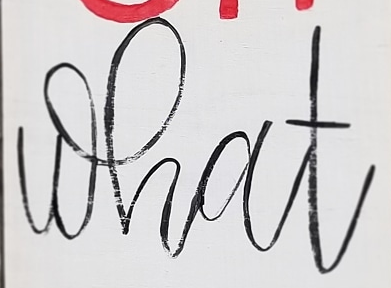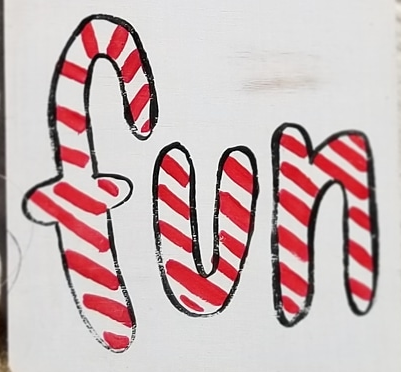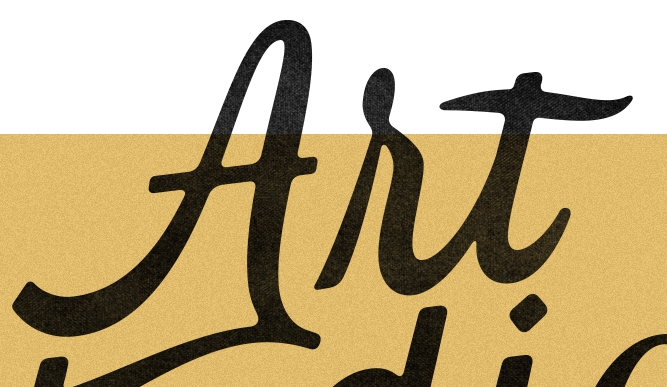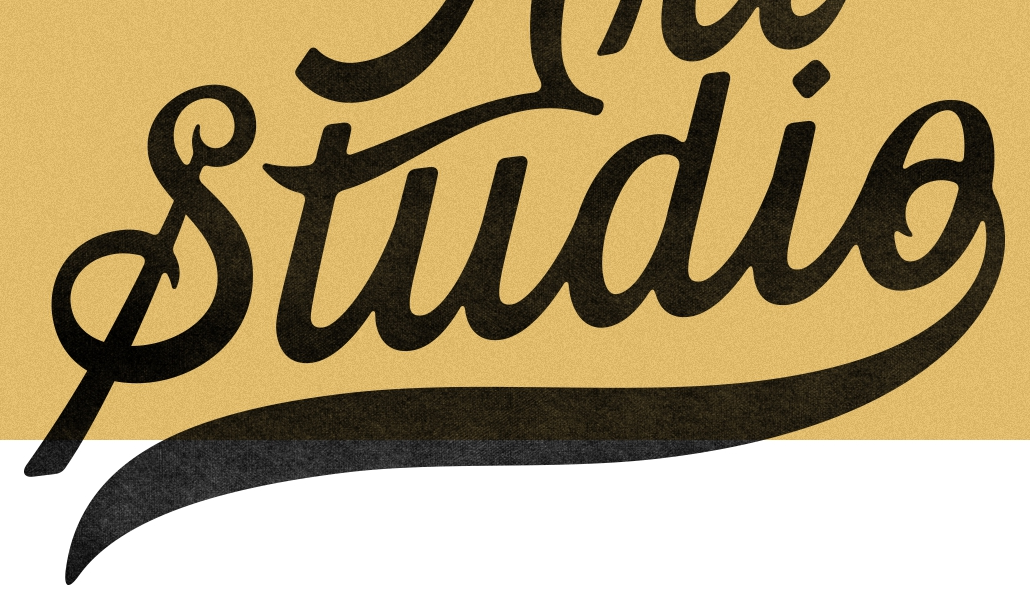Read the text content from these images in order, separated by a semicolon. what; fun; Art; Studio 